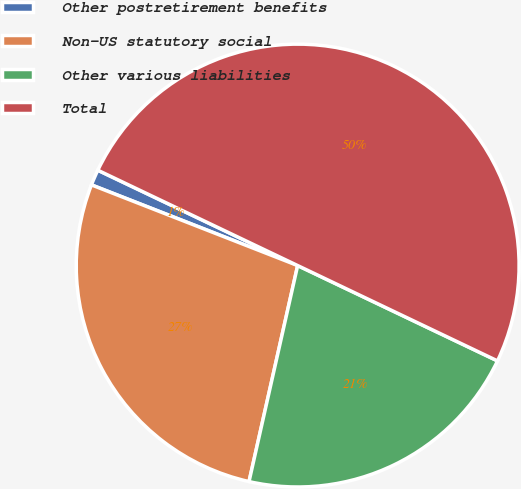Convert chart to OTSL. <chart><loc_0><loc_0><loc_500><loc_500><pie_chart><fcel>Other postretirement benefits<fcel>Non-US statutory social<fcel>Other various liabilities<fcel>Total<nl><fcel>1.15%<fcel>27.41%<fcel>21.44%<fcel>50.0%<nl></chart> 